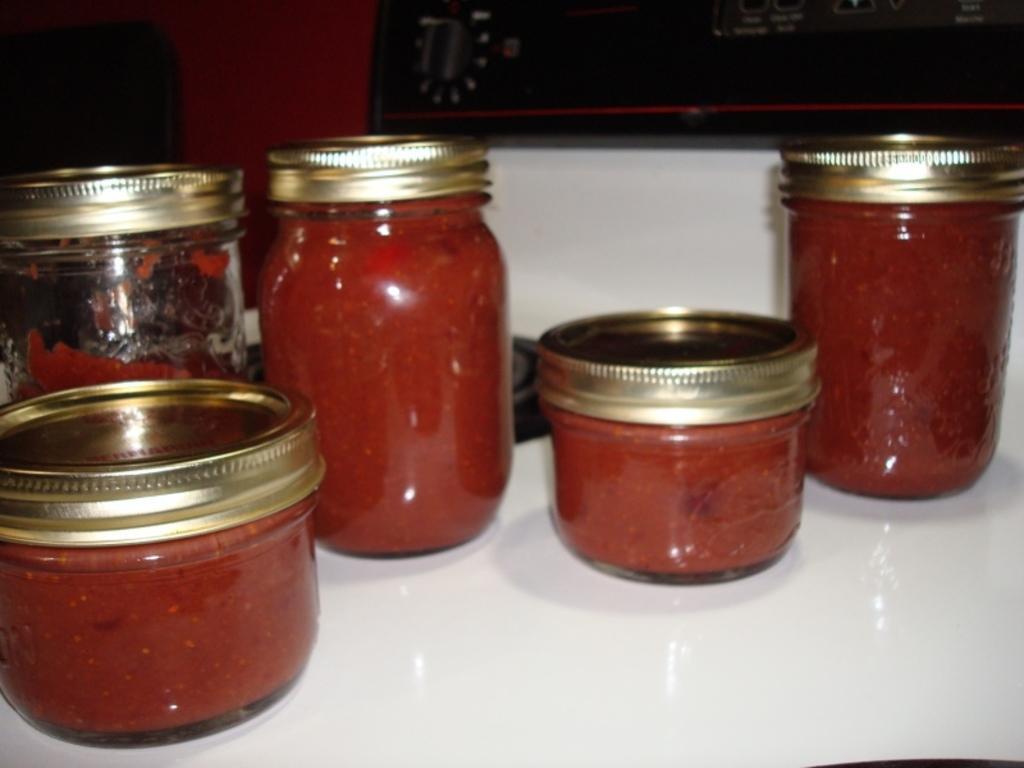Can you describe this image briefly? In this image, I can see the glass jars with the kids, which contains the food items. These glass jars are placed on a whiteboard. In the background, there is an object. 